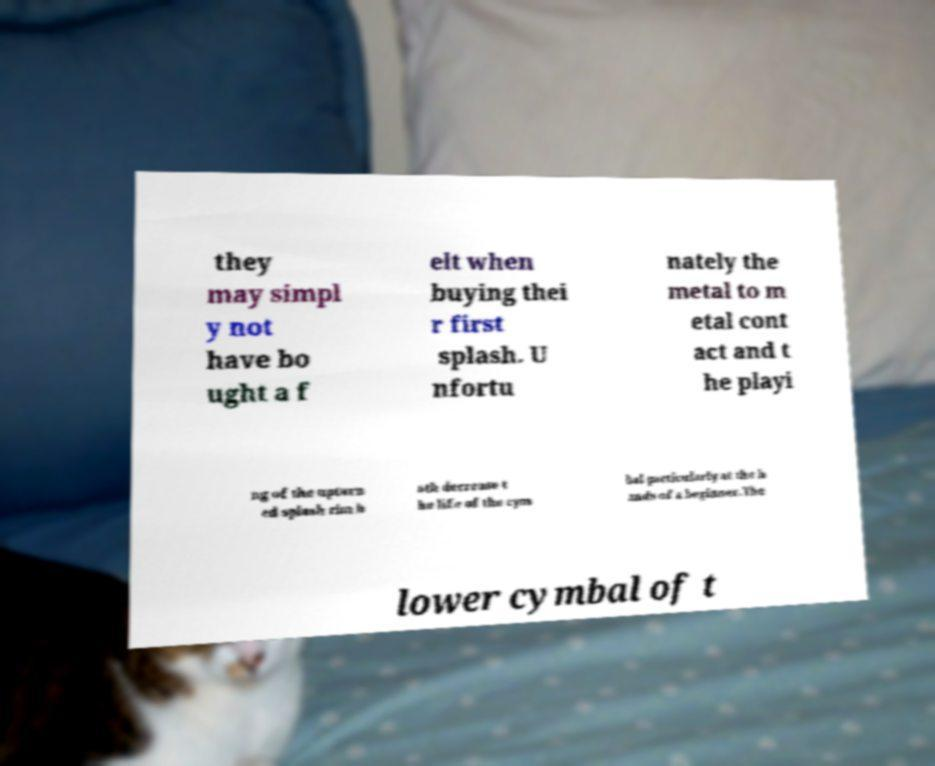For documentation purposes, I need the text within this image transcribed. Could you provide that? they may simpl y not have bo ught a f elt when buying thei r first splash. U nfortu nately the metal to m etal cont act and t he playi ng of the upturn ed splash rim b oth decrease t he life of the cym bal particularly at the h ands of a beginner.The lower cymbal of t 